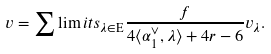Convert formula to latex. <formula><loc_0><loc_0><loc_500><loc_500>v = \sum \lim i t s _ { \lambda \in \mathrm E } \frac { f } { 4 \langle \alpha _ { 1 } ^ { \vee } , \lambda \rangle + 4 r - 6 } v _ { \lambda } .</formula> 